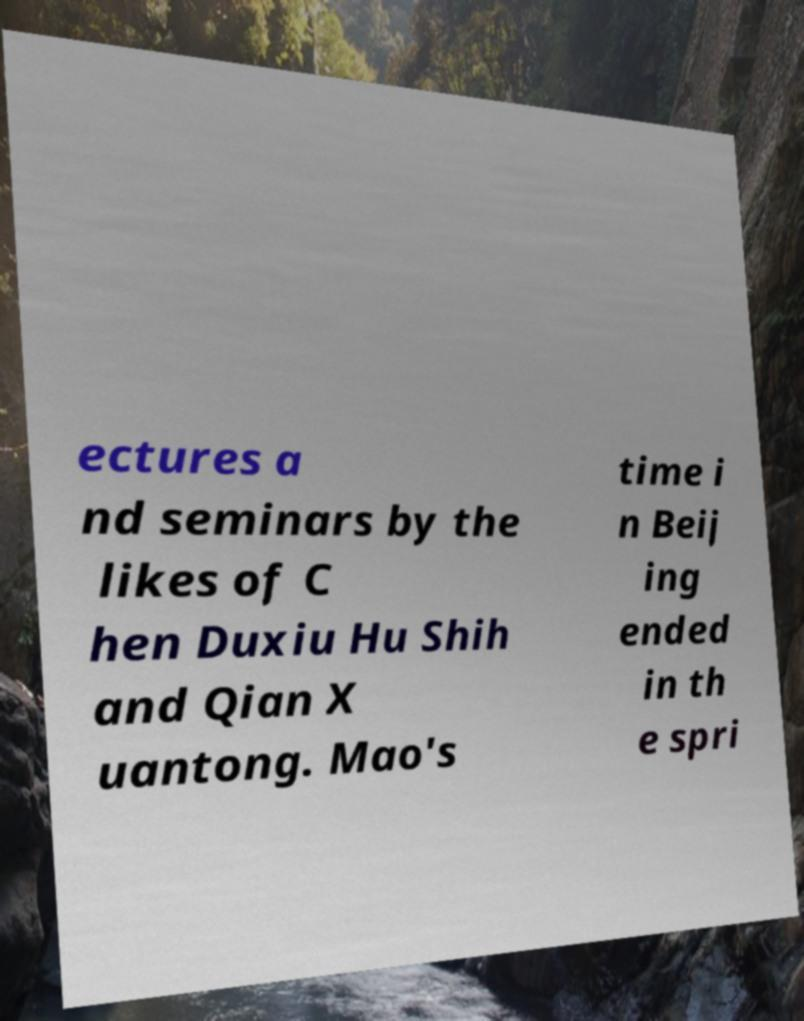Can you read and provide the text displayed in the image?This photo seems to have some interesting text. Can you extract and type it out for me? ectures a nd seminars by the likes of C hen Duxiu Hu Shih and Qian X uantong. Mao's time i n Beij ing ended in th e spri 